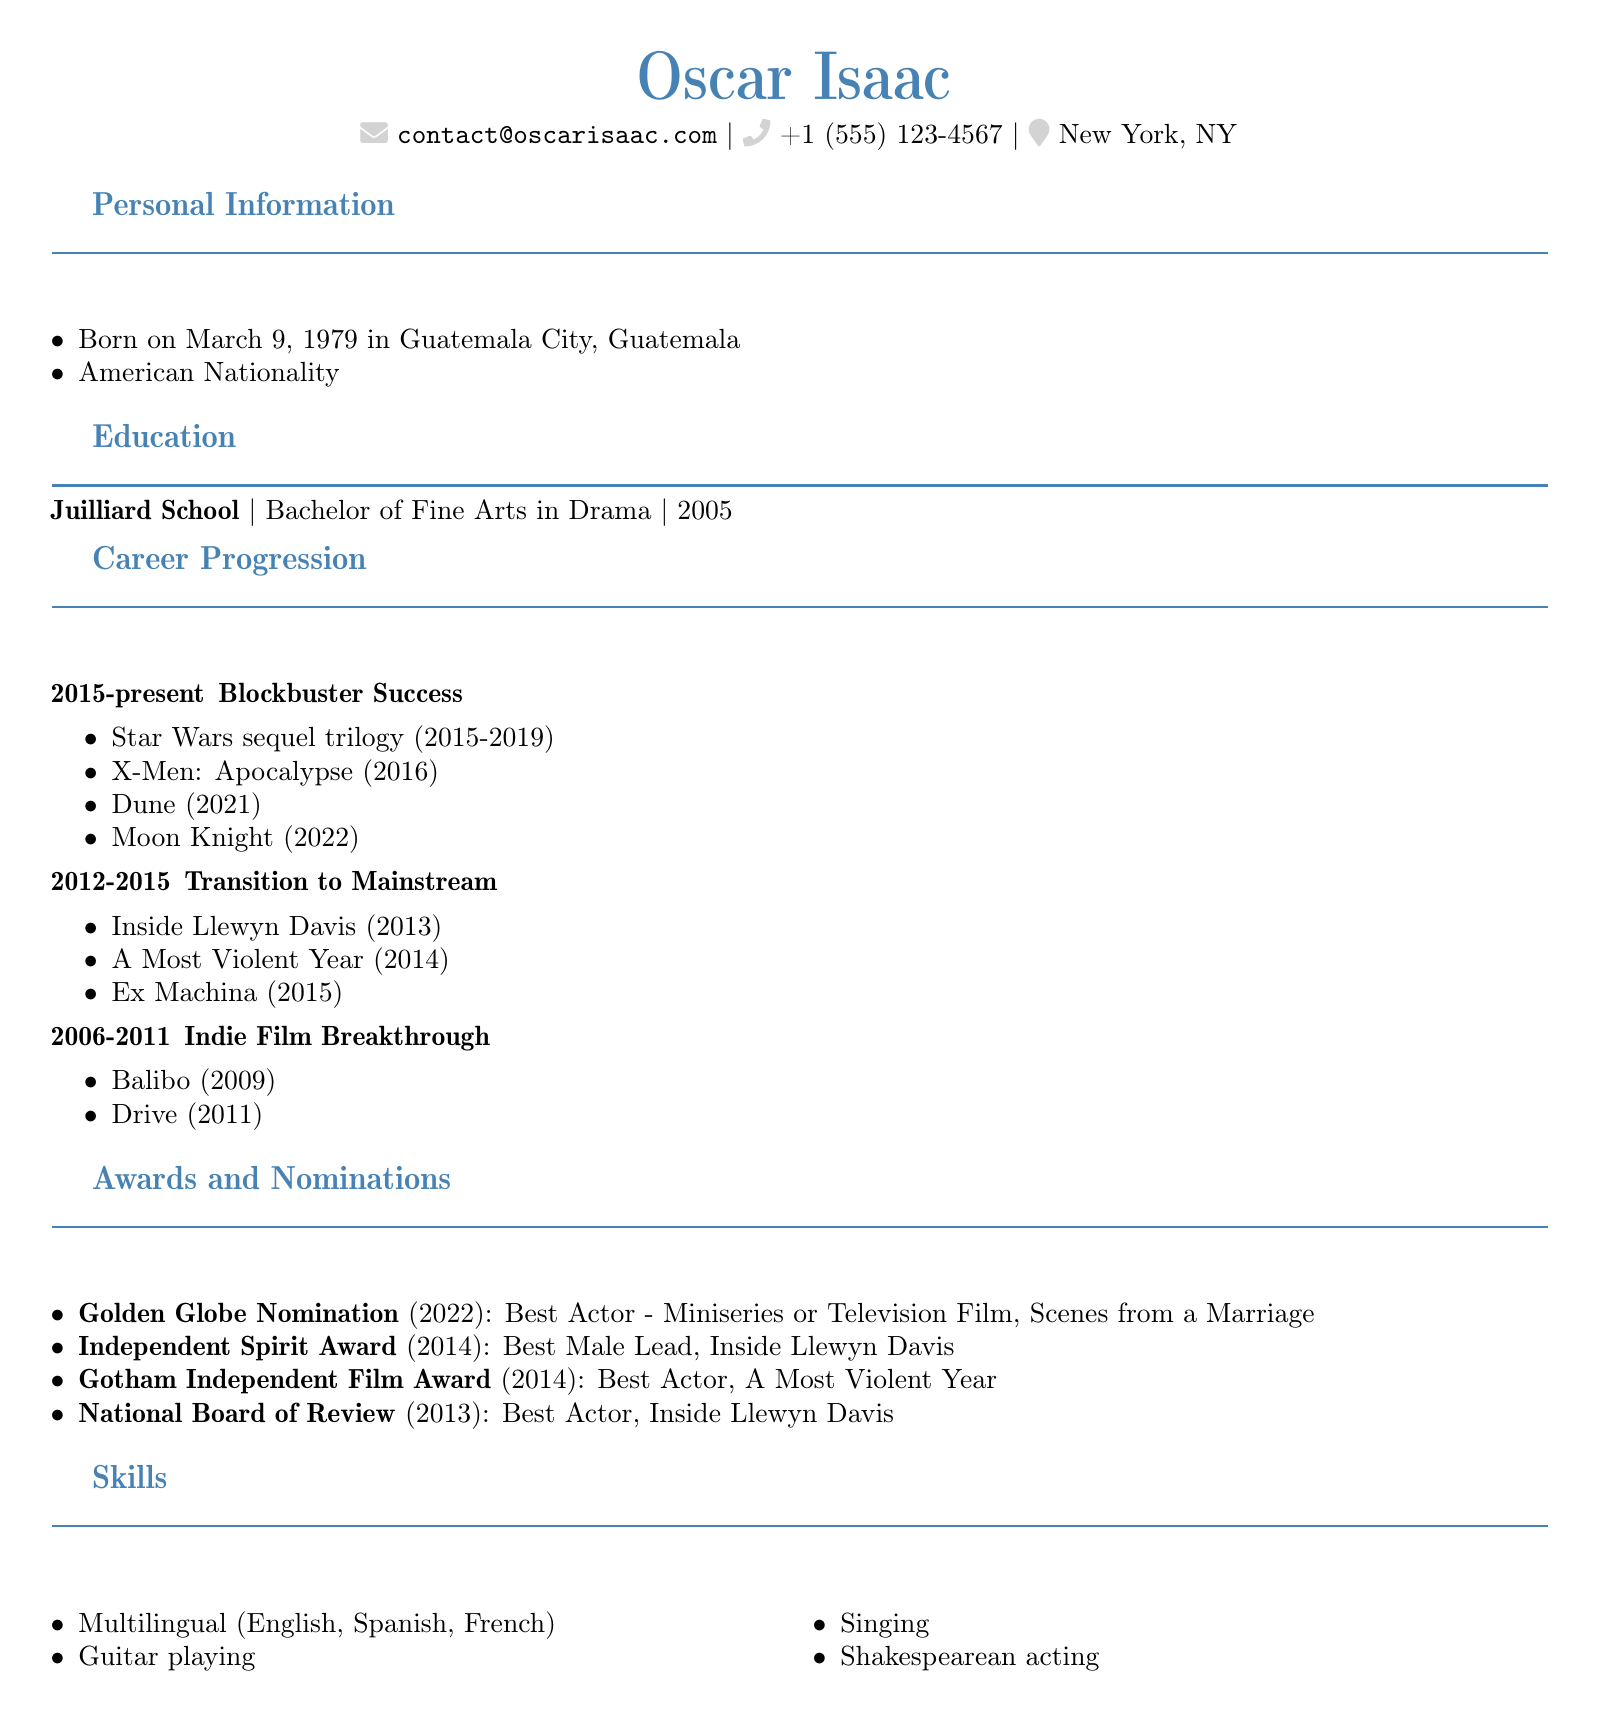What is Oscar Isaac's birth date? Oscar Isaac was born on March 9, 1979, as stated in the personal information section of the document.
Answer: March 9, 1979 Where did Oscar Isaac receive his education? The document states that Oscar Isaac attended the Juilliard School for his education.
Answer: Juilliard School Which award did Oscar Isaac win for "Inside Llewyn Davis"? According to the awards section, he won the Independent Spirit Award for Best Male Lead for this work.
Answer: Independent Spirit Award What notable work is associated with Oscar Isaac from 2014? The document lists A Most Violent Year as one of the notable works from the 2012-2015 period.
Answer: A Most Violent Year In which year was Isaac nominated for a Golden Globe? The awards section reveals that Isaac was nominated for a Golden Globe in 2022.
Answer: 2022 What is one skill listed in Oscar Isaac's CV? The skills section of the document includes "Guitar playing" as one of Isaac's skills.
Answer: Guitar playing How many notable works are listed in the Blockbuster Success period? The document lists four notable works during the 2015-present period in his career.
Answer: Four Which film from 2016 is mentioned in Isaac's career progression? X-Men: Apocalypse is mentioned as a notable work in the Blockbuster Success section.
Answer: X-Men: Apocalypse What degree did Oscar Isaac earn from Juilliard? The document states that he earned a Bachelor of Fine Arts in Drama.
Answer: Bachelor of Fine Arts in Drama 